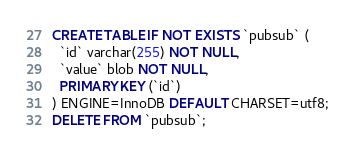<code> <loc_0><loc_0><loc_500><loc_500><_SQL_>CREATE TABLE IF NOT EXISTS `pubsub` (
  `id` varchar(255) NOT NULL,
  `value` blob NOT NULL,
  PRIMARY KEY (`id`)
) ENGINE=InnoDB DEFAULT CHARSET=utf8;
DELETE FROM `pubsub`;
</code> 